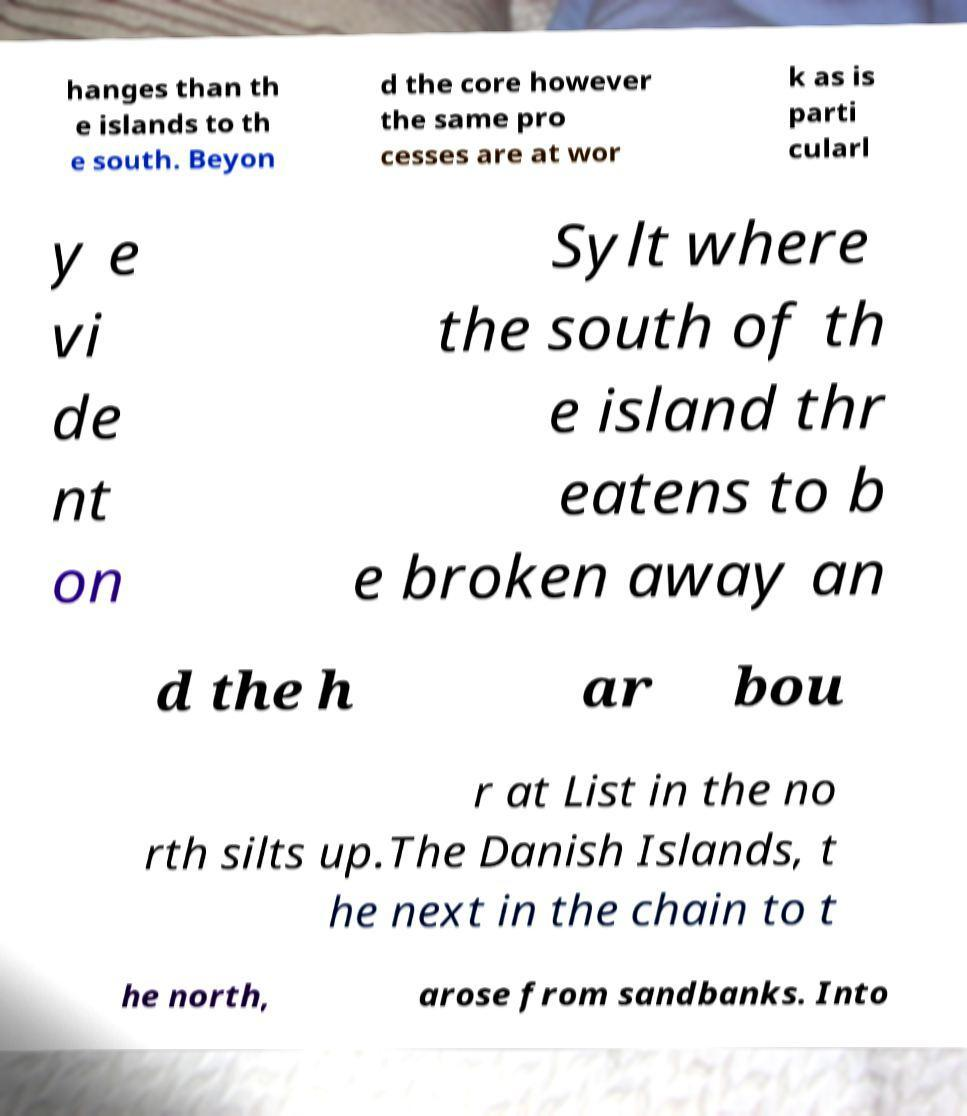I need the written content from this picture converted into text. Can you do that? hanges than th e islands to th e south. Beyon d the core however the same pro cesses are at wor k as is parti cularl y e vi de nt on Sylt where the south of th e island thr eatens to b e broken away an d the h ar bou r at List in the no rth silts up.The Danish Islands, t he next in the chain to t he north, arose from sandbanks. Into 